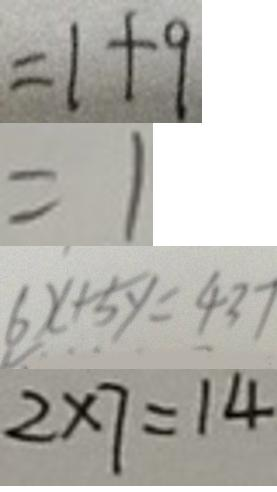Convert formula to latex. <formula><loc_0><loc_0><loc_500><loc_500>= 1 + 9 
 = 1 
 6 x + 5 y = 4 3 7 
 2 \times 7 = 1 4</formula> 